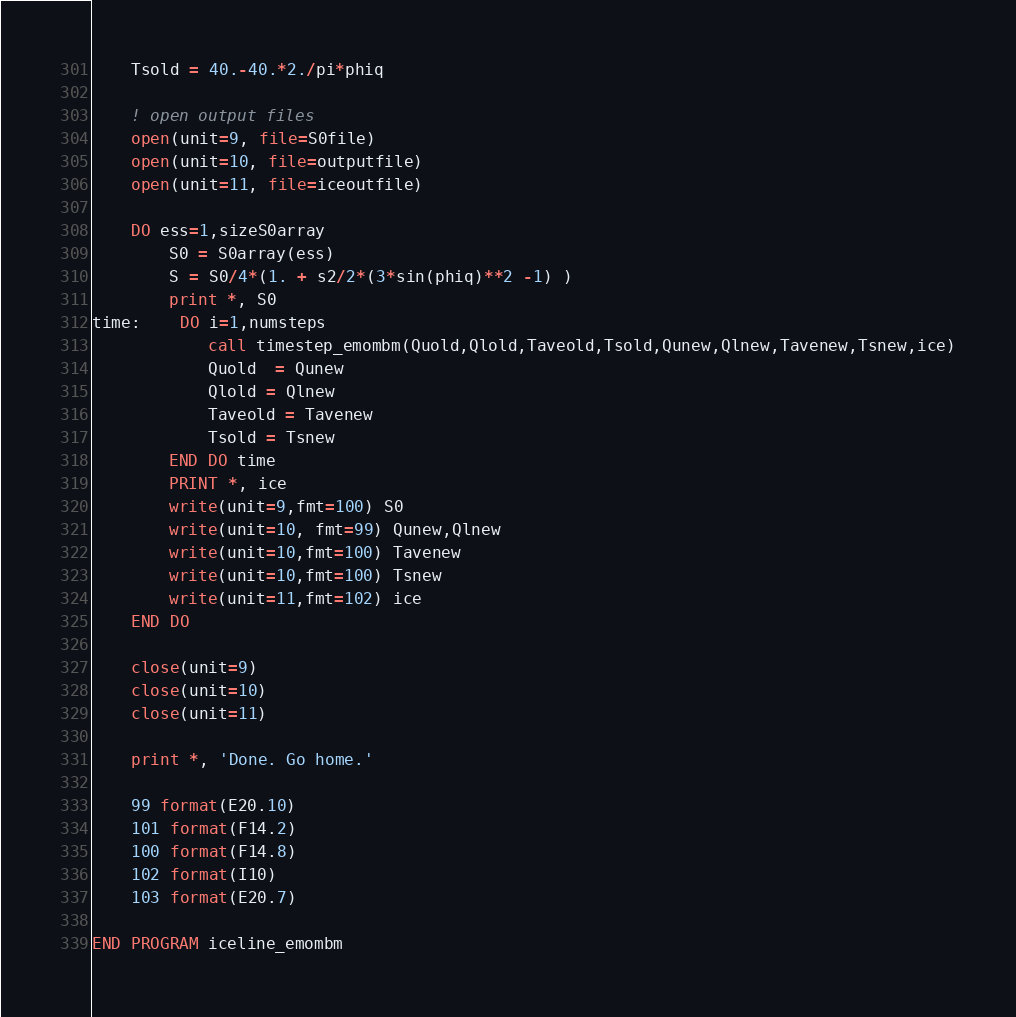Convert code to text. <code><loc_0><loc_0><loc_500><loc_500><_FORTRAN_>	Tsold = 40.-40.*2./pi*phiq	
	
	! open output files
	open(unit=9, file=S0file)
	open(unit=10, file=outputfile)
	open(unit=11, file=iceoutfile)
	
	DO ess=1,sizeS0array
		S0 = S0array(ess)
		S = S0/4*(1. + s2/2*(3*sin(phiq)**2 -1) )
		print *, S0
time:	DO i=1,numsteps
			call timestep_emombm(Quold,Qlold,Taveold,Tsold,Qunew,Qlnew,Tavenew,Tsnew,ice)
			Quold  = Qunew
			Qlold = Qlnew
			Taveold = Tavenew
			Tsold = Tsnew
		END DO time
		PRINT *, ice
		write(unit=9,fmt=100) S0
		write(unit=10, fmt=99) Qunew,Qlnew
		write(unit=10,fmt=100) Tavenew
		write(unit=10,fmt=100) Tsnew
		write(unit=11,fmt=102) ice
	END DO
	
	close(unit=9)
	close(unit=10)
	close(unit=11)
	
	print *, 'Done. Go home.'
	
	99 format(E20.10)
	101 format(F14.2)
	100 format(F14.8)
	102 format(I10)
	103 format(E20.7)

END PROGRAM iceline_emombm</code> 